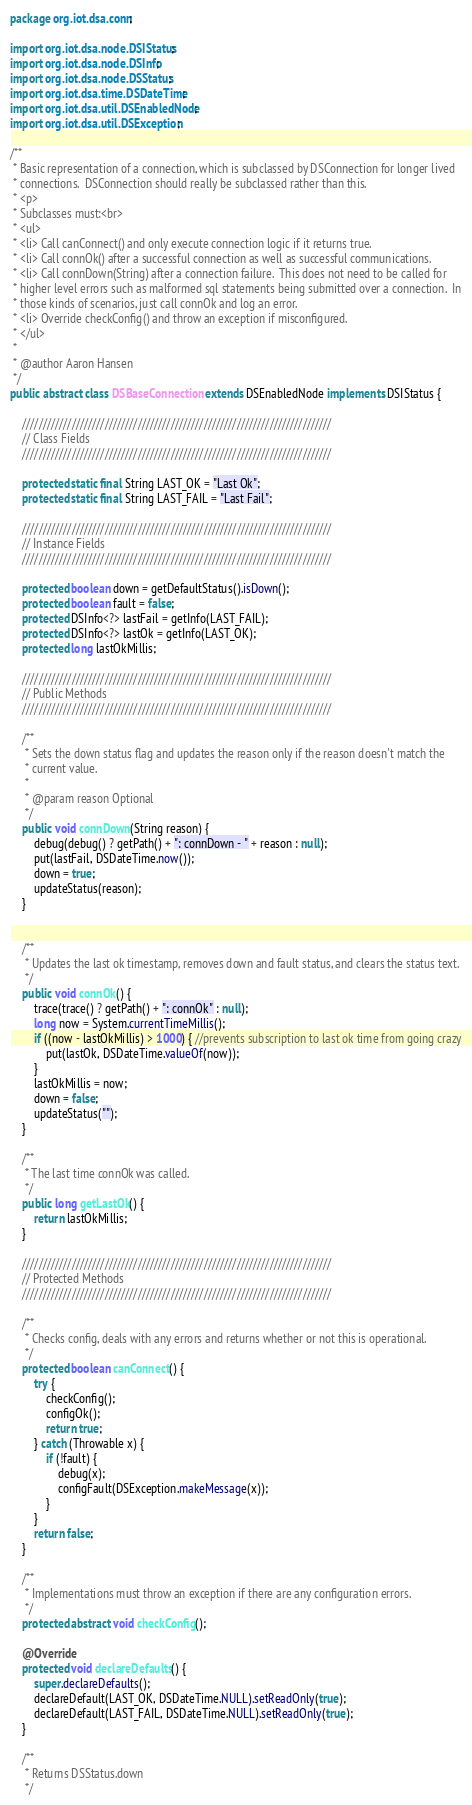<code> <loc_0><loc_0><loc_500><loc_500><_Java_>package org.iot.dsa.conn;

import org.iot.dsa.node.DSIStatus;
import org.iot.dsa.node.DSInfo;
import org.iot.dsa.node.DSStatus;
import org.iot.dsa.time.DSDateTime;
import org.iot.dsa.util.DSEnabledNode;
import org.iot.dsa.util.DSException;

/**
 * Basic representation of a connection, which is subclassed by DSConnection for longer lived
 * connections.  DSConnection should really be subclassed rather than this.
 * <p>
 * Subclasses must:<br>
 * <ul>
 * <li> Call canConnect() and only execute connection logic if it returns true.
 * <li> Call connOk() after a successful connection as well as successful communications.
 * <li> Call connDown(String) after a connection failure.  This does not need to be called for
 * higher level errors such as malformed sql statements being submitted over a connection.  In
 * those kinds of scenarios, just call connOk and log an error.
 * <li> Override checkConfig() and throw an exception if misconfigured.
 * </ul>
 *
 * @author Aaron Hansen
 */
public abstract class DSBaseConnection extends DSEnabledNode implements DSIStatus {

    ///////////////////////////////////////////////////////////////////////////
    // Class Fields
    ///////////////////////////////////////////////////////////////////////////

    protected static final String LAST_OK = "Last Ok";
    protected static final String LAST_FAIL = "Last Fail";

    ///////////////////////////////////////////////////////////////////////////
    // Instance Fields
    ///////////////////////////////////////////////////////////////////////////

    protected boolean down = getDefaultStatus().isDown();
    protected boolean fault = false;
    protected DSInfo<?> lastFail = getInfo(LAST_FAIL);
    protected DSInfo<?> lastOk = getInfo(LAST_OK);
    protected long lastOkMillis;

    ///////////////////////////////////////////////////////////////////////////
    // Public Methods
    ///////////////////////////////////////////////////////////////////////////

    /**
     * Sets the down status flag and updates the reason only if the reason doesn't match the
     * current value.
     *
     * @param reason Optional
     */
    public void connDown(String reason) {
        debug(debug() ? getPath() + ": connDown - " + reason : null);
        put(lastFail, DSDateTime.now());
        down = true;
        updateStatus(reason);
    }


    /**
     * Updates the last ok timestamp, removes down and fault status, and clears the status text.
     */
    public void connOk() {
        trace(trace() ? getPath() + ": connOk" : null);
        long now = System.currentTimeMillis();
        if ((now - lastOkMillis) > 1000) { //prevents subscription to last ok time from going crazy
            put(lastOk, DSDateTime.valueOf(now));
        }
        lastOkMillis = now;
        down = false;
        updateStatus("");
    }

    /**
     * The last time connOk was called.
     */
    public long getLastOk() {
        return lastOkMillis;
    }

    ///////////////////////////////////////////////////////////////////////////
    // Protected Methods
    ///////////////////////////////////////////////////////////////////////////

    /**
     * Checks config, deals with any errors and returns whether or not this is operational.
     */
    protected boolean canConnect() {
        try {
            checkConfig();
            configOk();
            return true;
        } catch (Throwable x) {
            if (!fault) {
                debug(x);
                configFault(DSException.makeMessage(x));
            }
        }
        return false;
    }

    /**
     * Implementations must throw an exception if there are any configuration errors.
     */
    protected abstract void checkConfig();

    @Override
    protected void declareDefaults() {
        super.declareDefaults();
        declareDefault(LAST_OK, DSDateTime.NULL).setReadOnly(true);
        declareDefault(LAST_FAIL, DSDateTime.NULL).setReadOnly(true);
    }

    /**
     * Returns DSStatus.down
     */</code> 